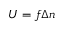<formula> <loc_0><loc_0><loc_500><loc_500>U = f \Delta n</formula> 